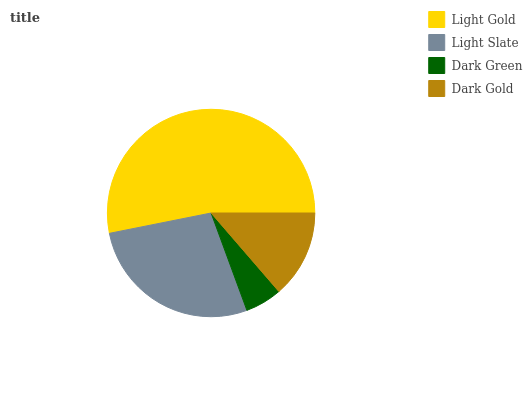Is Dark Green the minimum?
Answer yes or no. Yes. Is Light Gold the maximum?
Answer yes or no. Yes. Is Light Slate the minimum?
Answer yes or no. No. Is Light Slate the maximum?
Answer yes or no. No. Is Light Gold greater than Light Slate?
Answer yes or no. Yes. Is Light Slate less than Light Gold?
Answer yes or no. Yes. Is Light Slate greater than Light Gold?
Answer yes or no. No. Is Light Gold less than Light Slate?
Answer yes or no. No. Is Light Slate the high median?
Answer yes or no. Yes. Is Dark Gold the low median?
Answer yes or no. Yes. Is Dark Gold the high median?
Answer yes or no. No. Is Dark Green the low median?
Answer yes or no. No. 